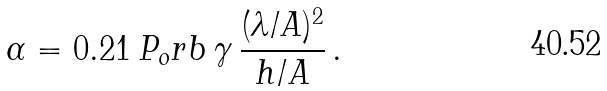<formula> <loc_0><loc_0><loc_500><loc_500>\alpha = 0 . 2 1 \, P _ { o } r b \, \gamma \, \frac { ( \lambda / A ) ^ { 2 } } { h / A } \, .</formula> 